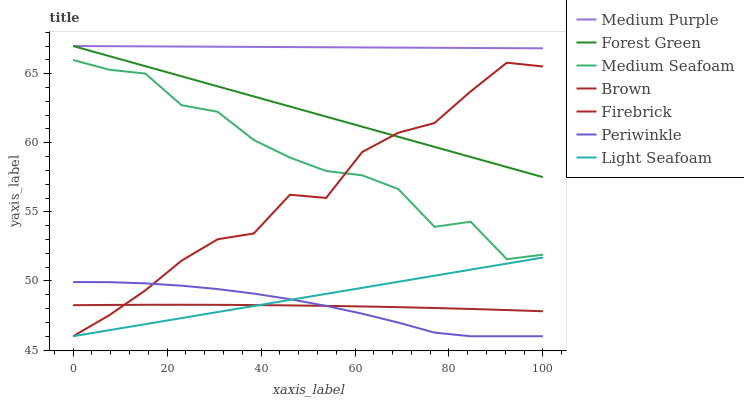Does Periwinkle have the minimum area under the curve?
Answer yes or no. Yes. Does Medium Purple have the maximum area under the curve?
Answer yes or no. Yes. Does Firebrick have the minimum area under the curve?
Answer yes or no. No. Does Firebrick have the maximum area under the curve?
Answer yes or no. No. Is Light Seafoam the smoothest?
Answer yes or no. Yes. Is Medium Seafoam the roughest?
Answer yes or no. Yes. Is Firebrick the smoothest?
Answer yes or no. No. Is Firebrick the roughest?
Answer yes or no. No. Does Firebrick have the lowest value?
Answer yes or no. Yes. Does Medium Purple have the lowest value?
Answer yes or no. No. Does Forest Green have the highest value?
Answer yes or no. Yes. Does Firebrick have the highest value?
Answer yes or no. No. Is Firebrick less than Medium Purple?
Answer yes or no. Yes. Is Medium Purple greater than Medium Seafoam?
Answer yes or no. Yes. Does Light Seafoam intersect Firebrick?
Answer yes or no. Yes. Is Light Seafoam less than Firebrick?
Answer yes or no. No. Is Light Seafoam greater than Firebrick?
Answer yes or no. No. Does Firebrick intersect Medium Purple?
Answer yes or no. No. 